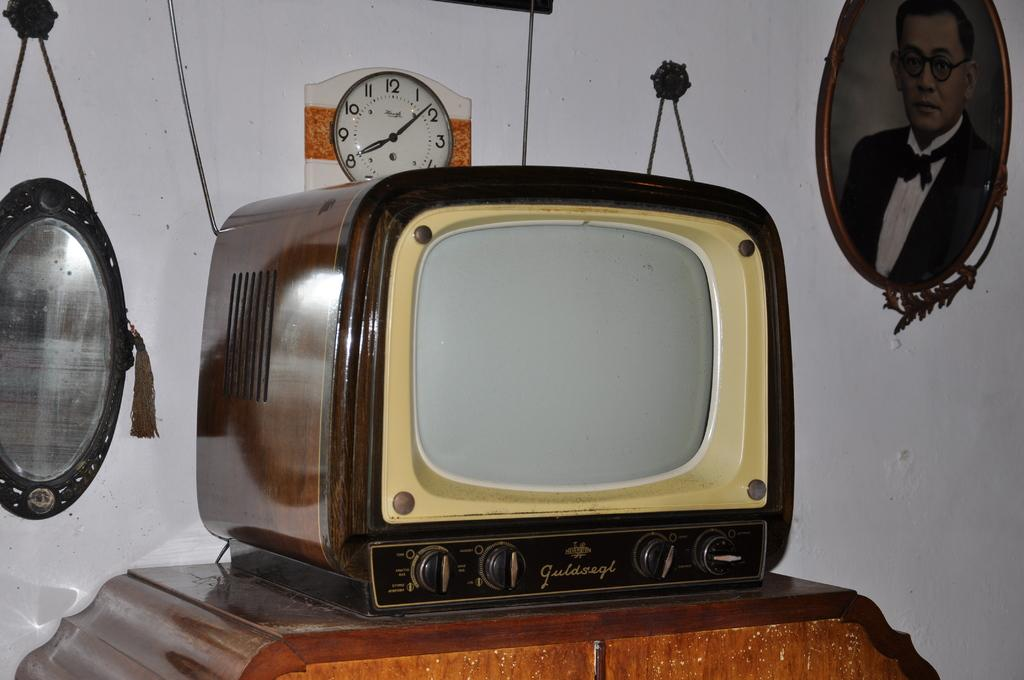<image>
Present a compact description of the photo's key features. A Guldsegl brand TV is atop a wooden cabinet, with a clock on the wall behind it. 